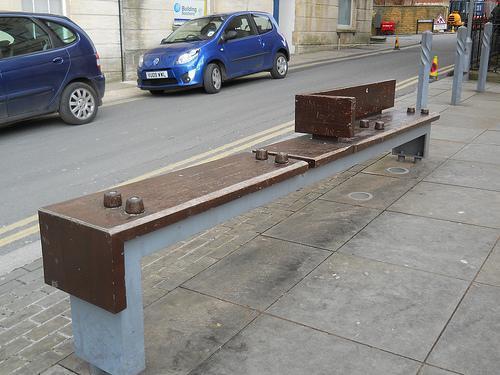How many cars in the picture?
Give a very brief answer. 2. 